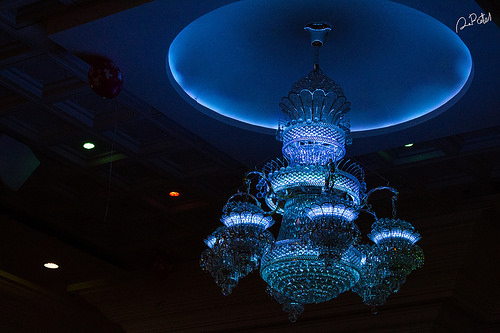<image>
Is the this light in front of the chandelier? No. The this light is not in front of the chandelier. The spatial positioning shows a different relationship between these objects. 